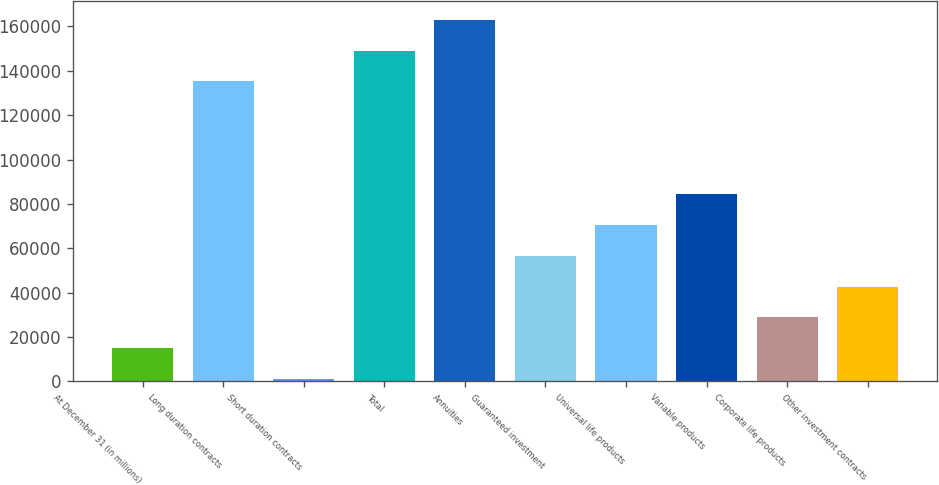<chart> <loc_0><loc_0><loc_500><loc_500><bar_chart><fcel>At December 31 (in millions)<fcel>Long duration contracts<fcel>Short duration contracts<fcel>Total<fcel>Annuities<fcel>Guaranteed investment<fcel>Universal life products<fcel>Variable products<fcel>Corporate life products<fcel>Other investment contracts<nl><fcel>14823.8<fcel>135202<fcel>866<fcel>149160<fcel>163118<fcel>56697.2<fcel>70655<fcel>84612.8<fcel>28781.6<fcel>42739.4<nl></chart> 